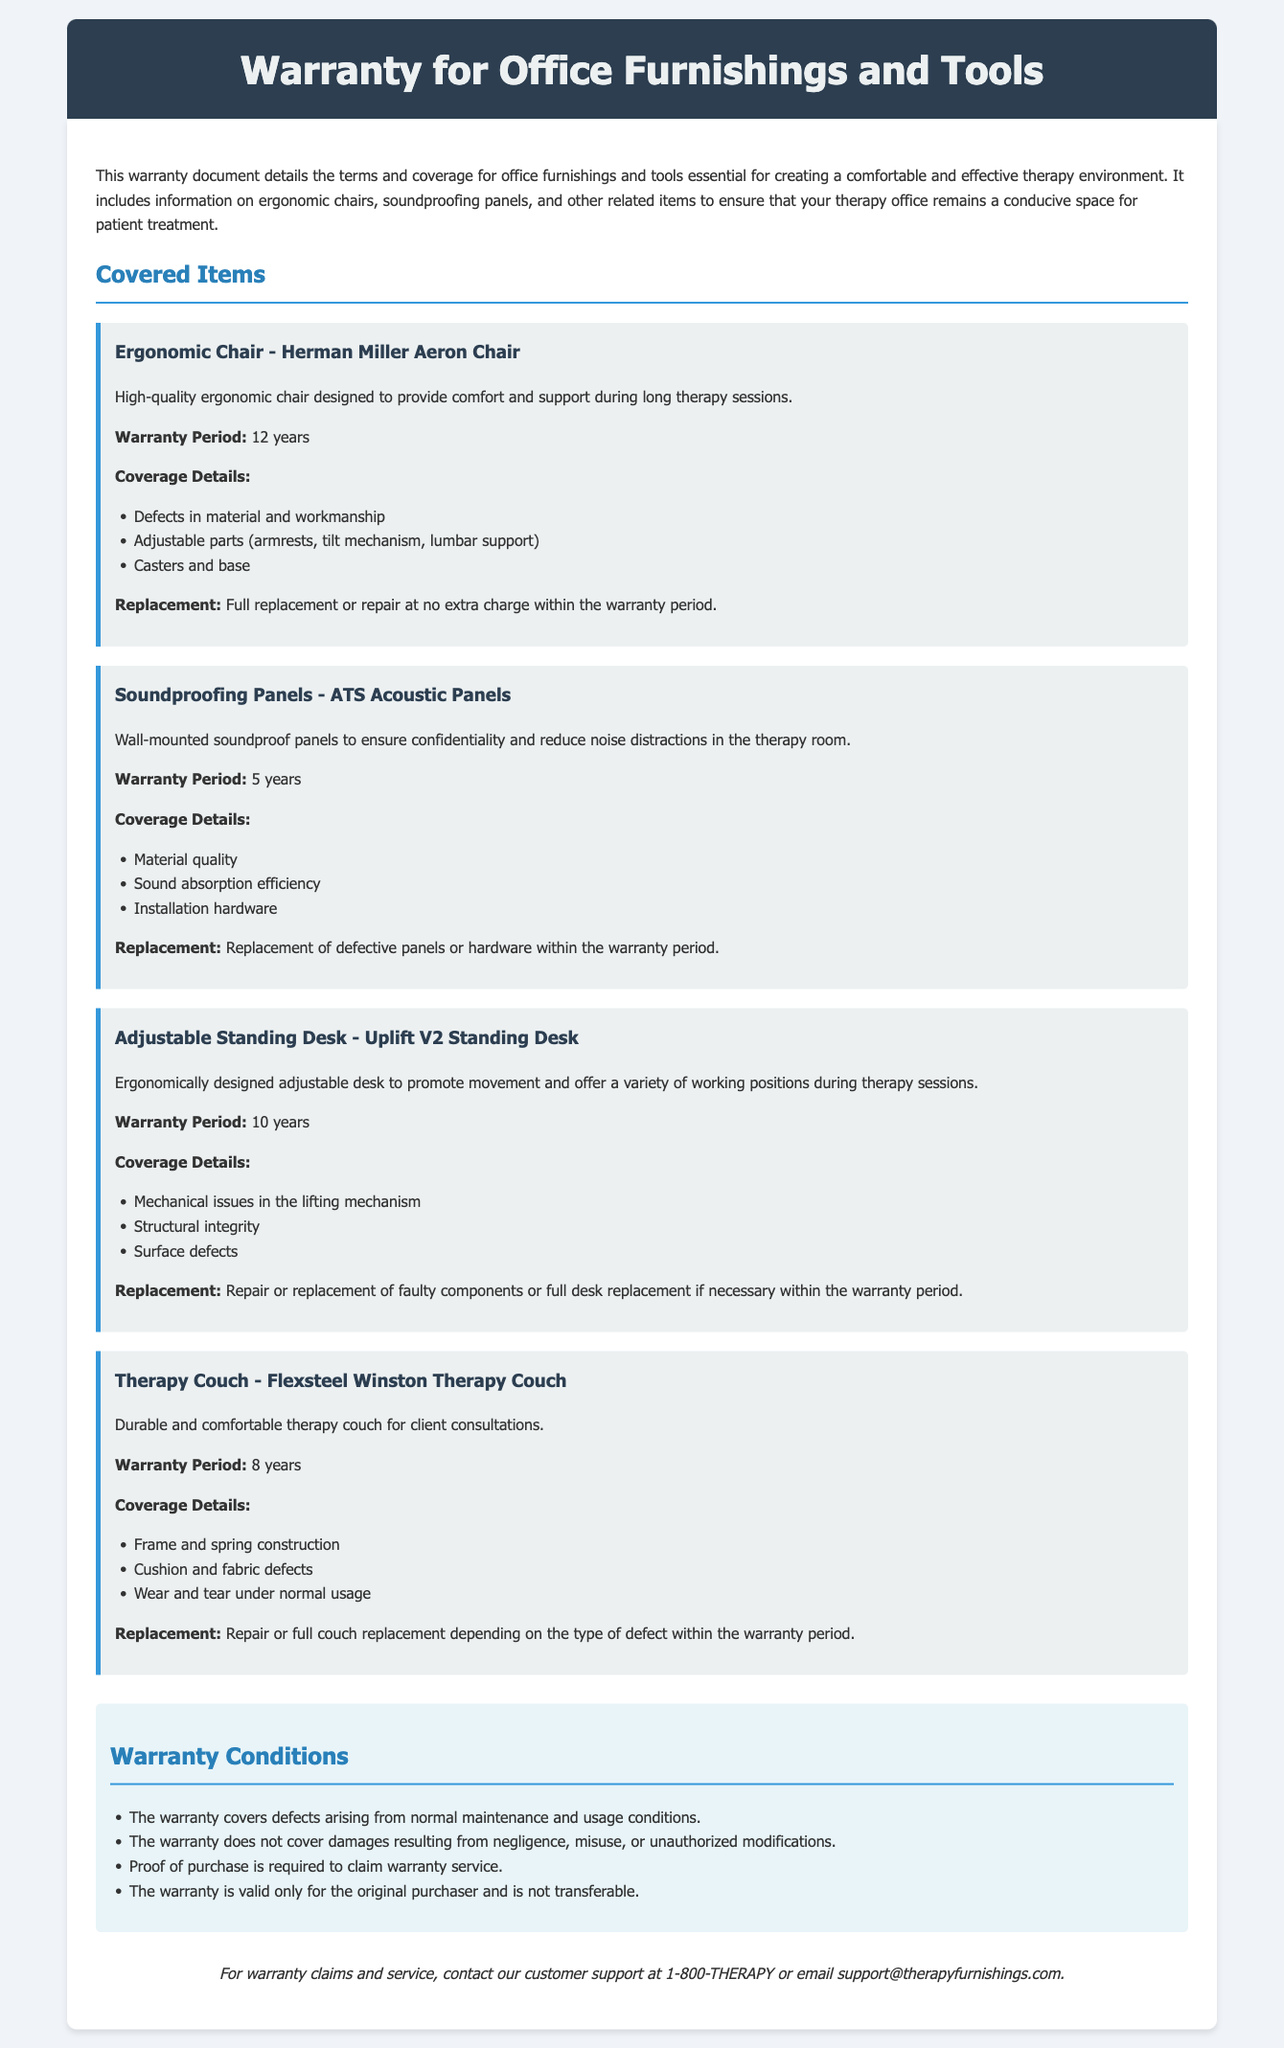What is the warranty period for the Herman Miller Aeron Chair? The warranty period is clearly specified in the document for each item; for the Herman Miller Aeron Chair, it is stated as 12 years.
Answer: 12 years What items are covered under this warranty? The document lists several items that are covered under the warranty, including ergonomic chairs and soundproofing panels.
Answer: Ergonomic chairs, soundproofing panels, adjustable standing desks, therapy couch What is the coverage detail for the Flexsteel Winston Therapy Couch? The document provides detailed coverage information for the Flexsteel Winston Therapy Couch, which includes aspects such as frame construction and fabric defects.
Answer: Frame and spring construction, cushion and fabric defects, wear and tear under normal usage How long is the warranty for the Uplift V2 Standing Desk? The warranty period for the Uplift V2 Standing Desk can easily be found in the listed details, which specify its coverage length.
Answer: 10 years What condition voids the warranty? The document specifies particular conditions under which the warranty is not applicable, such as damages from misuse.
Answer: Negligence, misuse, or unauthorized modifications What kind of replacement is offered for the defective soundproofing panels? The document outlines what replacement options are available for defective items; for soundproofing panels, it specifies the type of replacement.
Answer: Replacement of defective panels or hardware Who can claim the warranty? The document indicates that the warranty is valid only for a specific group of individuals, offering clarity on eligibility for claims.
Answer: The original purchaser What is required to claim warranty service? The document states a requirement necessary for initiating warranty service claims and ensures understanding of the procedure.
Answer: Proof of purchase 